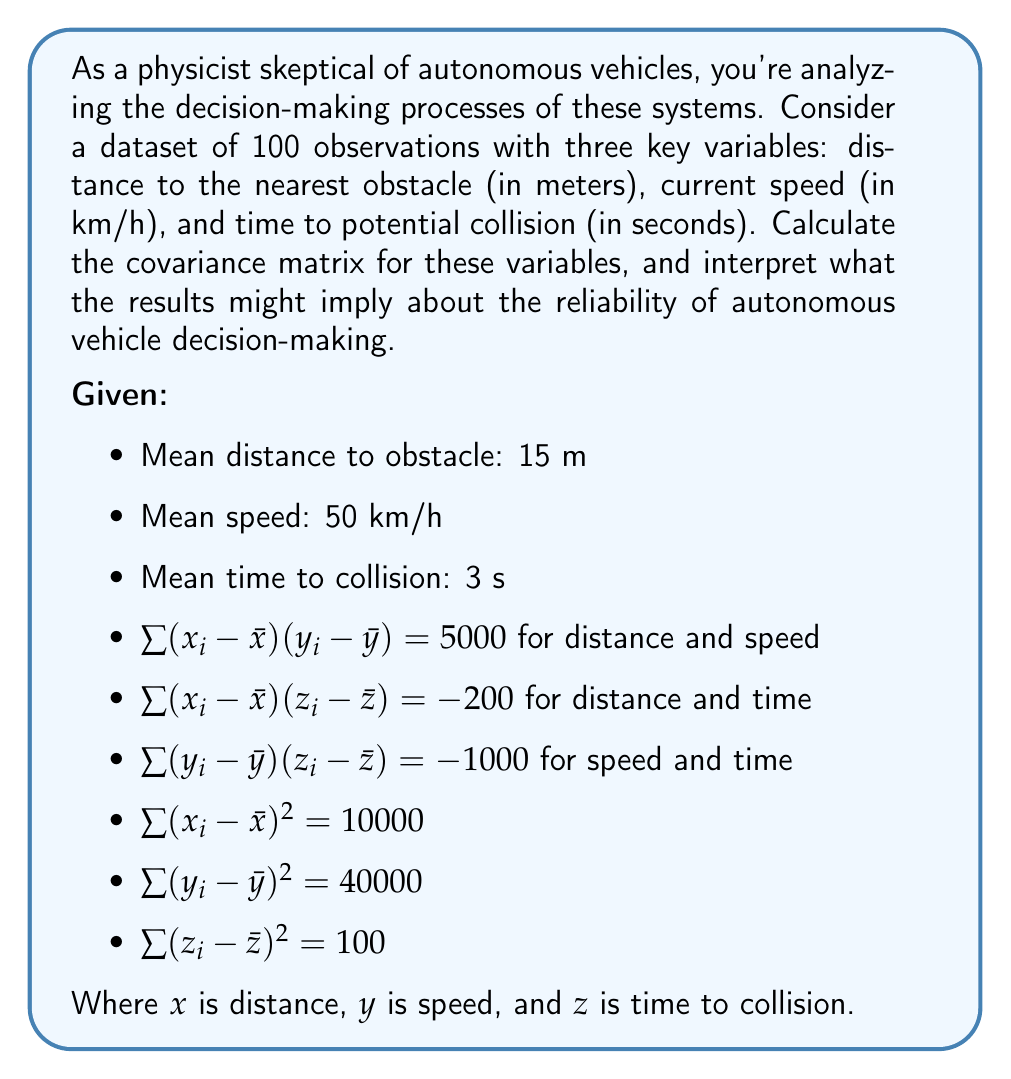Teach me how to tackle this problem. To calculate the covariance matrix, we need to determine the covariance between each pair of variables and the variance of each variable. The covariance matrix is symmetric, so we only need to calculate the upper or lower triangle.

1. Variance calculations:
   
   Variance of distance (x): $Var(x) = \frac{1}{n-1}\sum (x_i - \bar{x})^2 = \frac{10000}{99} \approx 101.01$
   
   Variance of speed (y): $Var(y) = \frac{1}{n-1}\sum (y_i - \bar{y})^2 = \frac{40000}{99} \approx 404.04$
   
   Variance of time to collision (z): $Var(z) = \frac{1}{n-1}\sum (z_i - \bar{z})^2 = \frac{100}{99} \approx 1.01$

2. Covariance calculations:
   
   Cov(x,y) = $\frac{1}{n-1}\sum (x_i - \bar{x})(y_i - \bar{y}) = \frac{5000}{99} \approx 50.51$
   
   Cov(x,z) = $\frac{1}{n-1}\sum (x_i - \bar{x})(z_i - \bar{z}) = \frac{-200}{99} \approx -2.02$
   
   Cov(y,z) = $\frac{1}{n-1}\sum (y_i - \bar{y})(z_i - \bar{z}) = \frac{-1000}{99} \approx -10.10$

3. Covariance matrix:

   $$\begin{bmatrix} 
   Var(x) & Cov(x,y) & Cov(x,z) \\
   Cov(x,y) & Var(y) & Cov(y,z) \\
   Cov(x,z) & Cov(y,z) & Var(z)
   \end{bmatrix}$$

   $$\begin{bmatrix} 
   101.01 & 50.51 & -2.02 \\
   50.51 & 404.04 & -10.10 \\
   -2.02 & -10.10 & 1.01
   \end{bmatrix}$$

Interpretation:
1. The positive covariance (50.51) between distance and speed suggests that as the distance to obstacles increases, the vehicle's speed tends to increase, which seems logical for safe autonomous driving.

2. The negative covariance (-2.02) between distance and time to collision indicates that as the distance to obstacles decreases, the time to potential collision increases slightly. This counterintuitive result might raise concerns about the system's ability to accurately assess collision risks.

3. The negative covariance (-10.10) between speed and time to collision suggests that as speed increases, the time to potential collision decreases, which is expected but highlights the critical nature of speed control in autonomous systems.

4. The relatively large variance in speed (404.04) compared to distance and time to collision might indicate significant fluctuations in vehicle speed, potentially raising questions about the smoothness and consistency of the autonomous driving system.

These results could support a skeptical view of autonomous vehicle decision-making, particularly regarding the system's ability to consistently and accurately assess collision risks across various scenarios.
Answer: The covariance matrix for the given variables is:

$$\begin{bmatrix} 
101.01 & 50.51 & -2.02 \\
50.51 & 404.04 & -10.10 \\
-2.02 & -10.10 & 1.01
\end{bmatrix}$$

This matrix reveals potential concerns about the autonomous vehicle's decision-making process, particularly in its assessment of collision risks and speed control. 